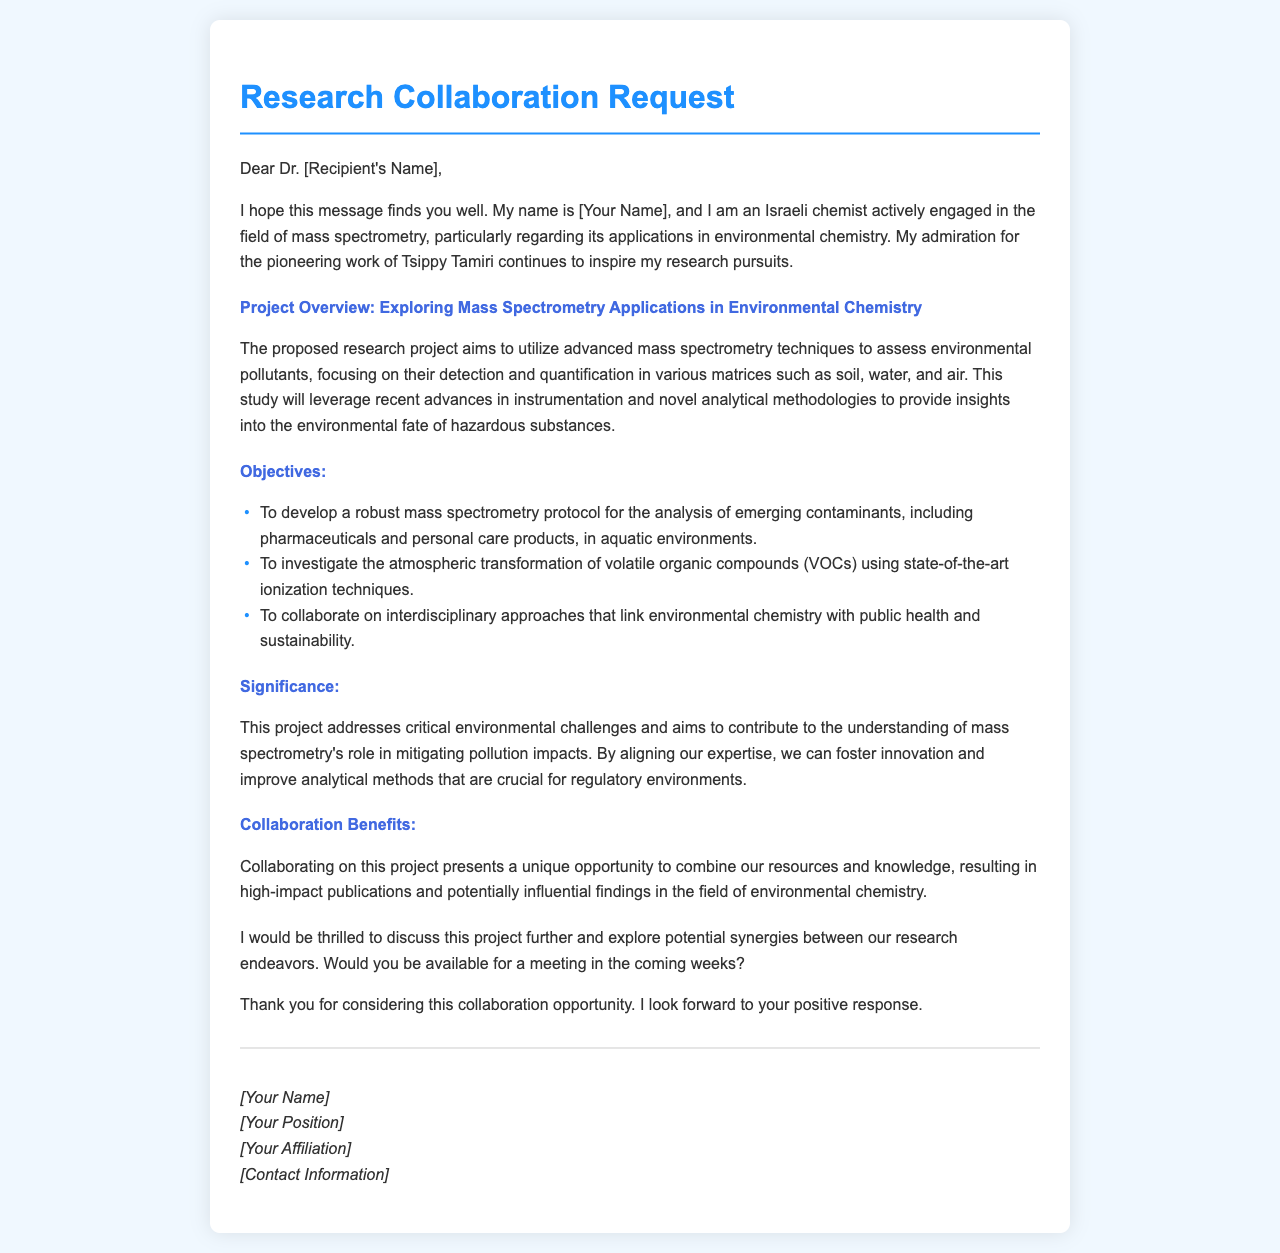What is the proposed research project about? The document states that the proposed research project aims to utilize advanced mass spectrometry techniques to assess environmental pollutants, focusing on their detection and quantification in various matrices such as soil, water, and air.
Answer: Assessing environmental pollutants Who is the recipient of the letter? The letter is addressed to "Dr. [Recipient's Name]," indicating that the recipient is a doctor, but the specific name is not provided in the document.
Answer: Dr. [Recipient's Name] What is one of the objectives of the project? One of the objectives listed is to develop a robust mass spectrometry protocol for the analysis of emerging contaminants, including pharmaceuticals and personal care products, in aquatic environments.
Answer: Develop a robust protocol What important environmental issue does the project aim to address? The project addresses critical environmental challenges and aims to contribute to the understanding of mass spectrometry's role in mitigating pollution impacts.
Answer: Pollution impacts What benefits does the collaboration promise? The letter mentions that collaborating on this project presents a unique opportunity to combine resources and knowledge, resulting in high-impact publications and potentially influential findings.
Answer: High-impact publications 